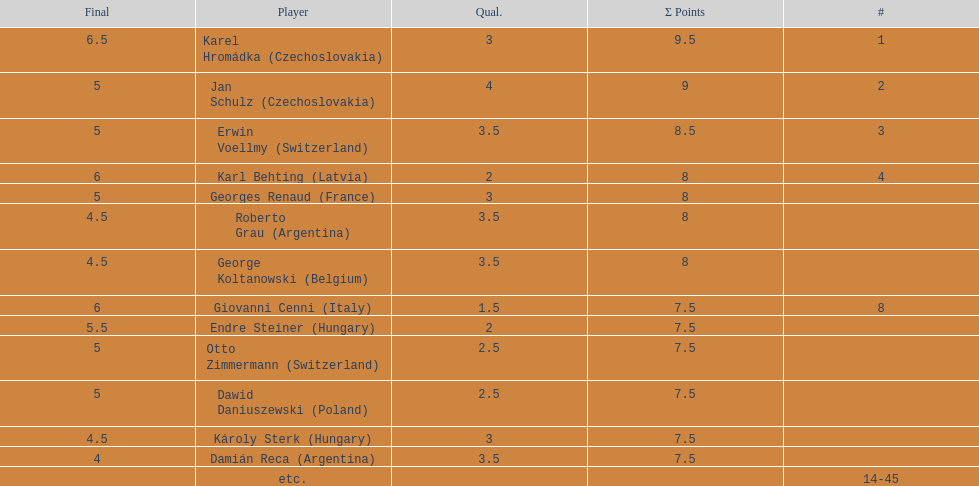Jan schulz is ranked immediately below which player? Karel Hromádka. Give me the full table as a dictionary. {'header': ['Final', 'Player', 'Qual.', 'Σ Points', '#'], 'rows': [['6.5', 'Karel Hromádka\xa0(Czechoslovakia)', '3', '9.5', '1'], ['5', 'Jan Schulz\xa0(Czechoslovakia)', '4', '9', '2'], ['5', 'Erwin Voellmy\xa0(Switzerland)', '3.5', '8.5', '3'], ['6', 'Karl Behting\xa0(Latvia)', '2', '8', '4'], ['5', 'Georges Renaud\xa0(France)', '3', '8', ''], ['4.5', 'Roberto Grau\xa0(Argentina)', '3.5', '8', ''], ['4.5', 'George Koltanowski\xa0(Belgium)', '3.5', '8', ''], ['6', 'Giovanni Cenni\xa0(Italy)', '1.5', '7.5', '8'], ['5.5', 'Endre Steiner\xa0(Hungary)', '2', '7.5', ''], ['5', 'Otto Zimmermann\xa0(Switzerland)', '2.5', '7.5', ''], ['5', 'Dawid Daniuszewski\xa0(Poland)', '2.5', '7.5', ''], ['4.5', 'Károly Sterk\xa0(Hungary)', '3', '7.5', ''], ['4', 'Damián Reca\xa0(Argentina)', '3.5', '7.5', ''], ['', 'etc.', '', '', '14-45']]} 